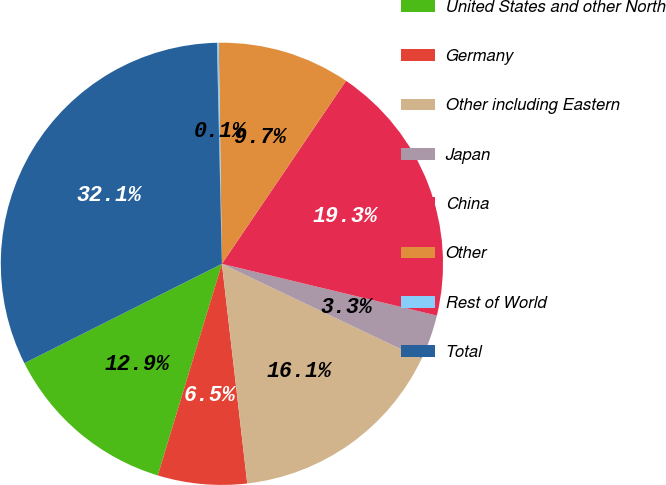Convert chart. <chart><loc_0><loc_0><loc_500><loc_500><pie_chart><fcel>United States and other North<fcel>Germany<fcel>Other including Eastern<fcel>Japan<fcel>China<fcel>Other<fcel>Rest of World<fcel>Total<nl><fcel>12.9%<fcel>6.51%<fcel>16.09%<fcel>3.32%<fcel>19.28%<fcel>9.71%<fcel>0.13%<fcel>32.06%<nl></chart> 